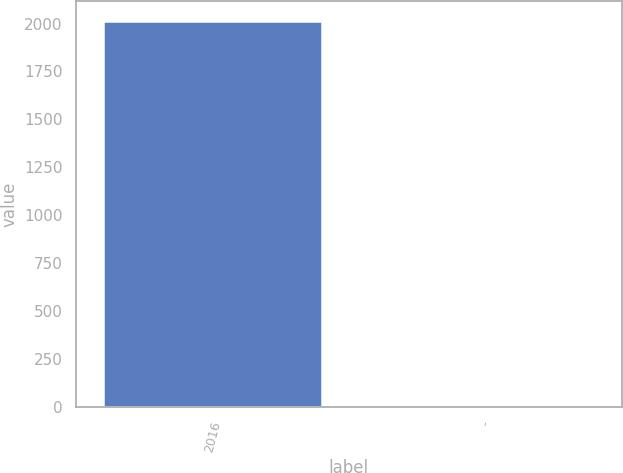<chart> <loc_0><loc_0><loc_500><loc_500><bar_chart><fcel>2016<fcel>-<nl><fcel>2015<fcel>0.1<nl></chart> 